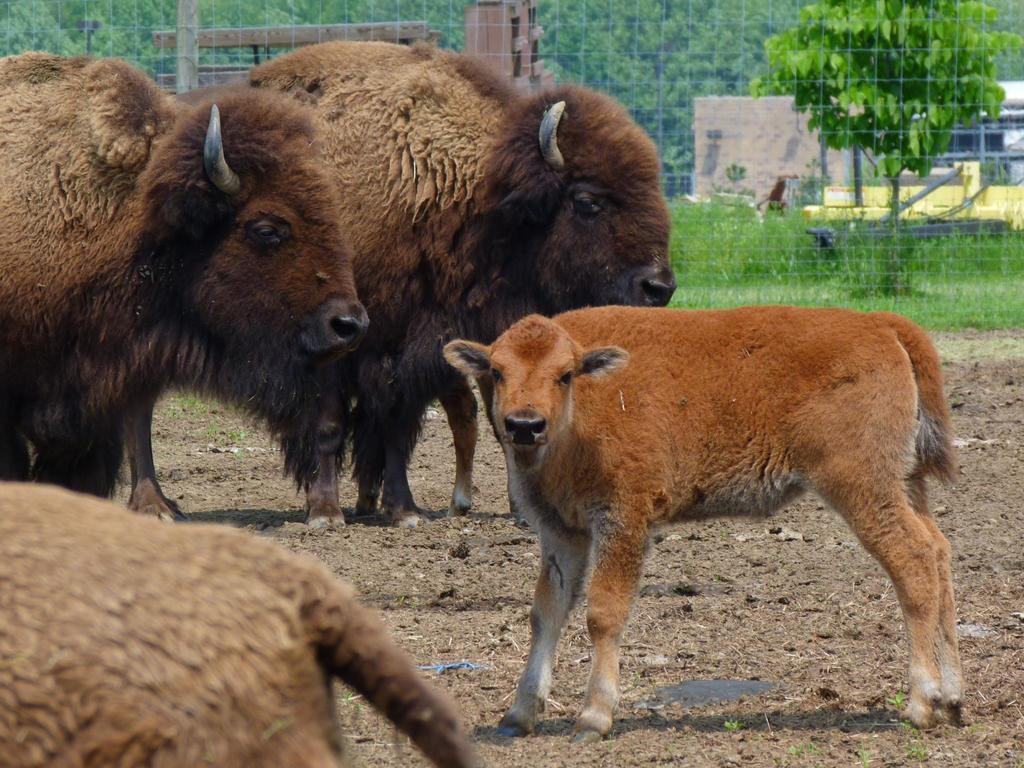What animals can be seen on the ground in the image? There are bisons on the ground in the image. Can you describe the baby bison in the image? There is a baby bison in the right corner of the image. What is located at the back of the image? There is a fencing at the back of the image. What type of vegetation is present in the image? There are trees and grass in the image. What type of sticks are being exchanged between the bisons in the image? There are no sticks present in the image, nor is there is there any indication of an exchange between the bisons. 